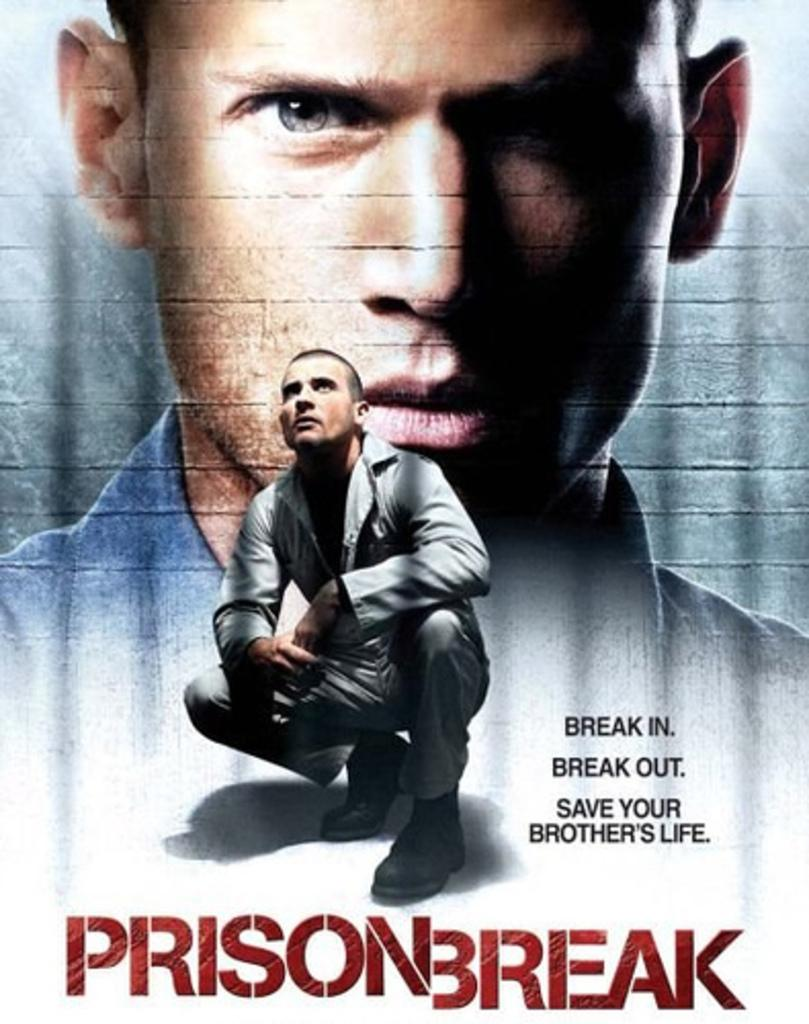<image>
Summarize the visual content of the image. a man standing and squating in a advertisement for a show called prisonbreak 